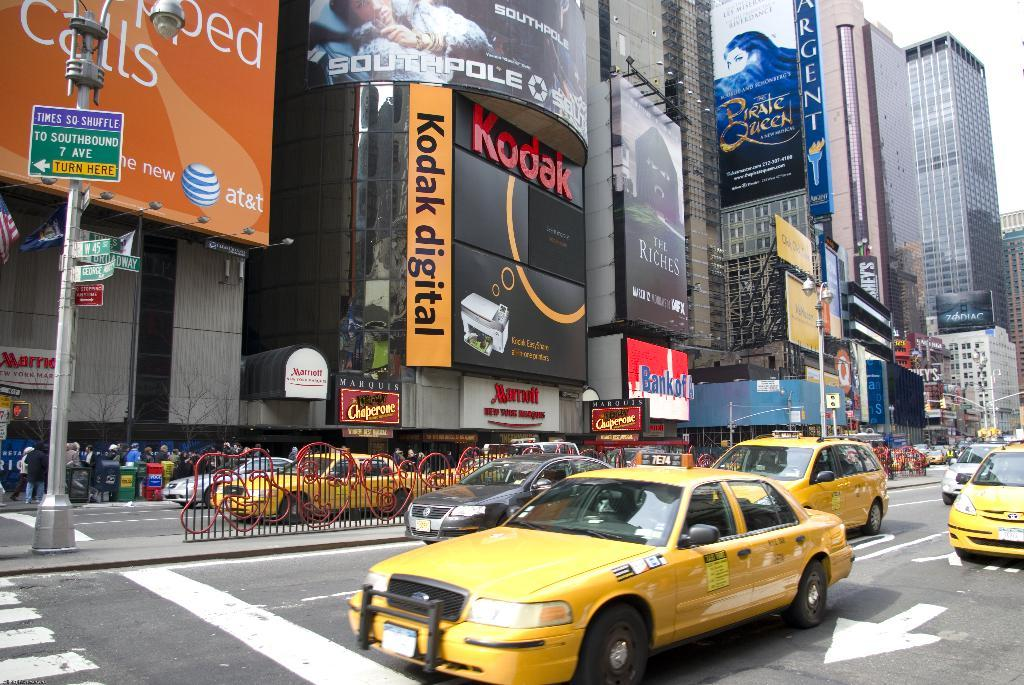<image>
Offer a succinct explanation of the picture presented. a kodak sign that is on the street 